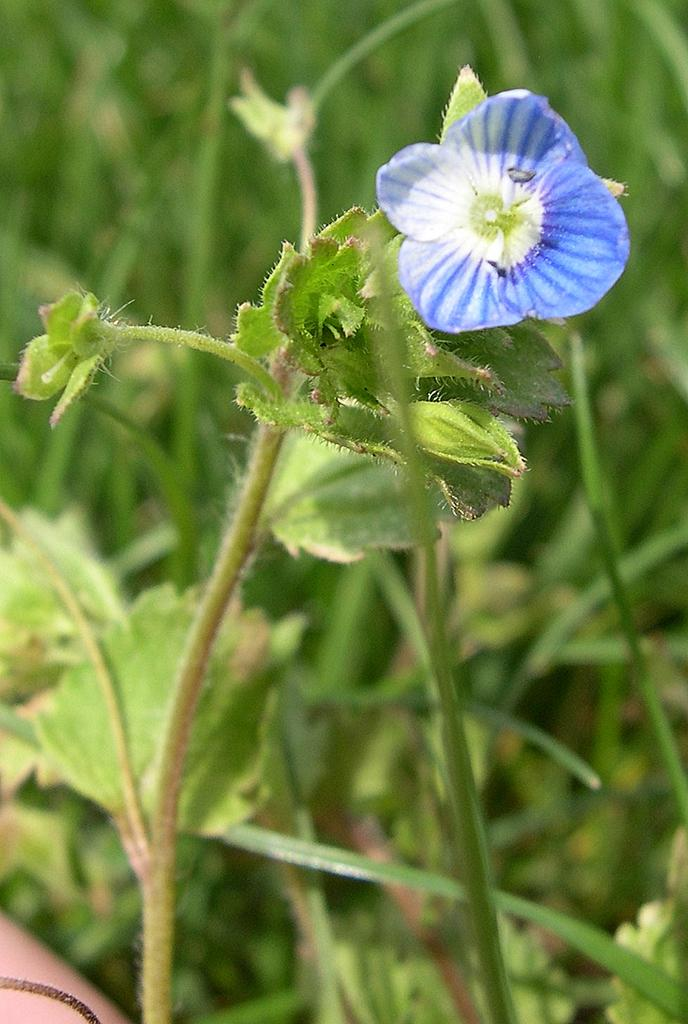What type of flower is in the image? There is a blue flower in the image. Where is the flower located? The flower is on a plant. What else can be seen in the image besides the flower? There are plants visible in the background of the image. What type of support does the flower provide in the image? The flower does not provide support in the image; it is a part of the plant and not an object that offers support. 